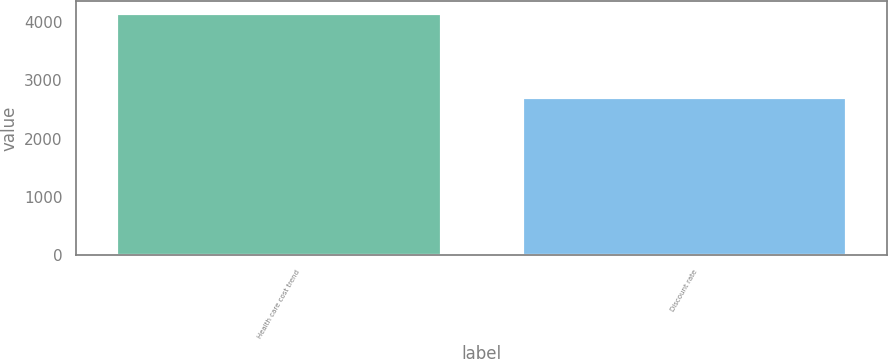Convert chart. <chart><loc_0><loc_0><loc_500><loc_500><bar_chart><fcel>Health care cost trend<fcel>Discount rate<nl><fcel>4150<fcel>2715<nl></chart> 